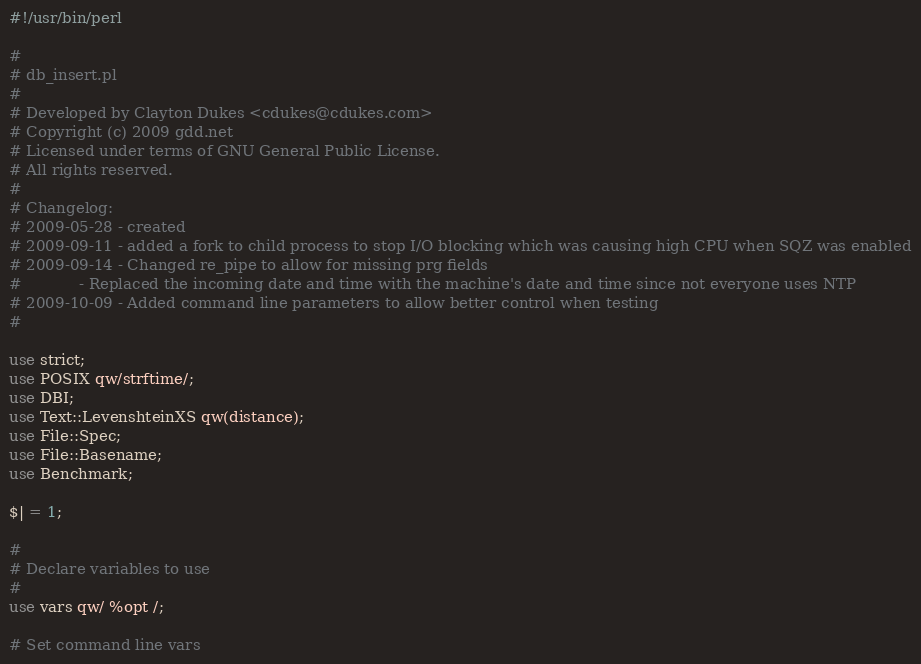<code> <loc_0><loc_0><loc_500><loc_500><_Perl_>#!/usr/bin/perl 

#
# db_insert.pl
#
# Developed by Clayton Dukes <cdukes@cdukes.com>
# Copyright (c) 2009 gdd.net
# Licensed under terms of GNU General Public License.
# All rights reserved.
#
# Changelog:
# 2009-05-28 - created
# 2009-09-11 - added a fork to child process to stop I/O blocking which was causing high CPU when SQZ was enabled
# 2009-09-14 - Changed re_pipe to allow for missing prg fields
#			 - Replaced the incoming date and time with the machine's date and time since not everyone uses NTP
# 2009-10-09 - Added command line parameters to allow better control when testing
#

use strict;
use POSIX qw/strftime/;
use DBI;
use Text::LevenshteinXS qw(distance);
use File::Spec;
use File::Basename;
use Benchmark;

$| = 1;

#
# Declare variables to use
#
use vars qw/ %opt /;

# Set command line vars</code> 